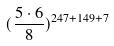Convert formula to latex. <formula><loc_0><loc_0><loc_500><loc_500>( \frac { 5 \cdot 6 } { 8 } ) ^ { 2 4 7 + 1 4 9 + 7 }</formula> 